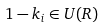<formula> <loc_0><loc_0><loc_500><loc_500>1 - k _ { i } \in U ( R )</formula> 